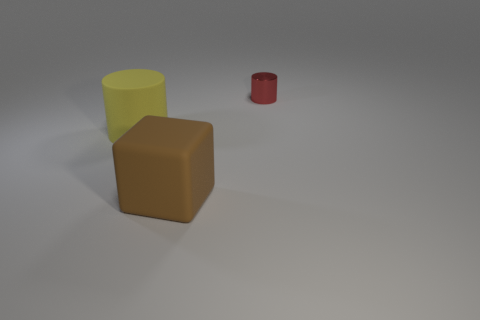Add 1 brown objects. How many objects exist? 4 Subtract all cylinders. How many objects are left? 1 Subtract 0 red cubes. How many objects are left? 3 Subtract all yellow matte balls. Subtract all small red shiny cylinders. How many objects are left? 2 Add 2 big brown rubber blocks. How many big brown rubber blocks are left? 3 Add 1 tiny purple rubber things. How many tiny purple rubber things exist? 1 